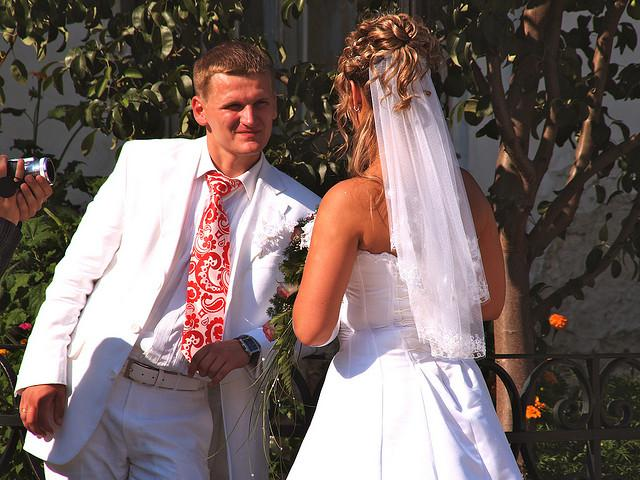What life event are they in the middle of celebrating? Please explain your reasoning. marriage. A woman in a white dress and a man in a suit are standing outside together and she is holding flowers. 